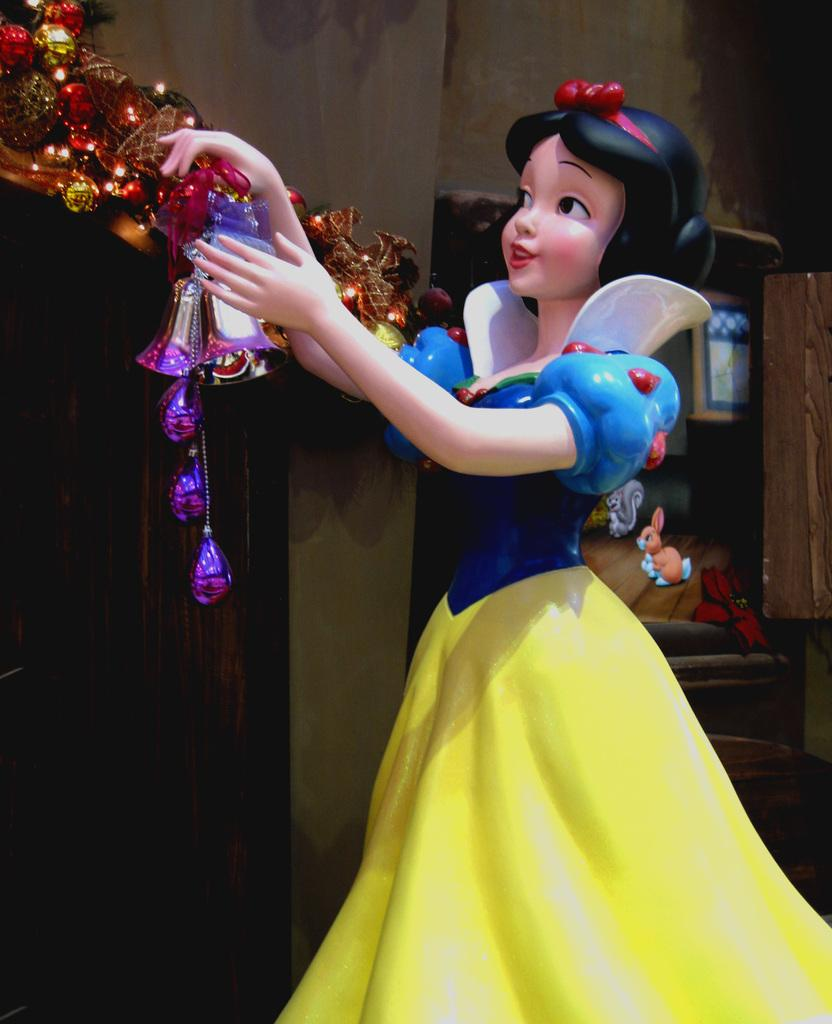What is the main subject of the image? There is a Barbie doll in the image. What is the Barbie doll holding in her hands? The Barbie doll is holding lights in her hands. What can be seen in the background of the image? There is a wall in the background of the image. What type of apples are hanging from the wall in the image? There are no apples present in the image; the Barbie doll is holding lights in her hands. 